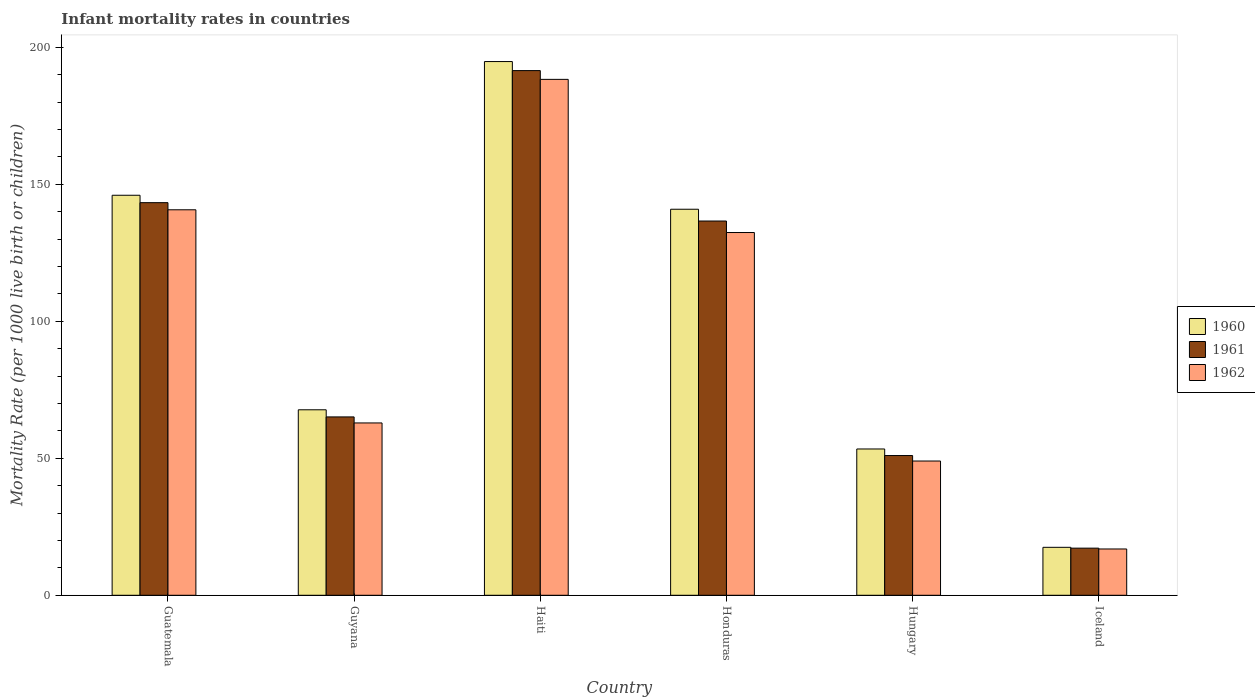How many different coloured bars are there?
Provide a succinct answer. 3. How many groups of bars are there?
Make the answer very short. 6. Are the number of bars per tick equal to the number of legend labels?
Offer a terse response. Yes. Are the number of bars on each tick of the X-axis equal?
Keep it short and to the point. Yes. How many bars are there on the 4th tick from the left?
Ensure brevity in your answer.  3. How many bars are there on the 6th tick from the right?
Your answer should be very brief. 3. What is the label of the 2nd group of bars from the left?
Ensure brevity in your answer.  Guyana. Across all countries, what is the maximum infant mortality rate in 1961?
Your answer should be compact. 191.5. Across all countries, what is the minimum infant mortality rate in 1962?
Your answer should be compact. 16.9. In which country was the infant mortality rate in 1962 maximum?
Offer a terse response. Haiti. What is the total infant mortality rate in 1960 in the graph?
Offer a very short reply. 620.3. What is the difference between the infant mortality rate in 1960 in Guyana and that in Honduras?
Offer a terse response. -73.2. What is the difference between the infant mortality rate in 1962 in Haiti and the infant mortality rate in 1961 in Honduras?
Make the answer very short. 51.7. What is the average infant mortality rate in 1960 per country?
Provide a succinct answer. 103.38. What is the difference between the infant mortality rate of/in 1961 and infant mortality rate of/in 1960 in Iceland?
Make the answer very short. -0.3. In how many countries, is the infant mortality rate in 1961 greater than 120?
Provide a succinct answer. 3. What is the ratio of the infant mortality rate in 1962 in Haiti to that in Honduras?
Provide a short and direct response. 1.42. What is the difference between the highest and the second highest infant mortality rate in 1961?
Your answer should be compact. 6.7. What is the difference between the highest and the lowest infant mortality rate in 1960?
Your response must be concise. 177.3. Is the sum of the infant mortality rate in 1961 in Hungary and Iceland greater than the maximum infant mortality rate in 1962 across all countries?
Offer a terse response. No. Is it the case that in every country, the sum of the infant mortality rate in 1961 and infant mortality rate in 1962 is greater than the infant mortality rate in 1960?
Offer a terse response. Yes. Are all the bars in the graph horizontal?
Offer a terse response. No. How many countries are there in the graph?
Keep it short and to the point. 6. What is the difference between two consecutive major ticks on the Y-axis?
Your answer should be very brief. 50. How many legend labels are there?
Offer a terse response. 3. What is the title of the graph?
Keep it short and to the point. Infant mortality rates in countries. Does "1968" appear as one of the legend labels in the graph?
Offer a very short reply. No. What is the label or title of the Y-axis?
Your answer should be compact. Mortality Rate (per 1000 live birth or children). What is the Mortality Rate (per 1000 live birth or children) of 1960 in Guatemala?
Your answer should be compact. 146. What is the Mortality Rate (per 1000 live birth or children) in 1961 in Guatemala?
Your response must be concise. 143.3. What is the Mortality Rate (per 1000 live birth or children) of 1962 in Guatemala?
Give a very brief answer. 140.7. What is the Mortality Rate (per 1000 live birth or children) of 1960 in Guyana?
Offer a terse response. 67.7. What is the Mortality Rate (per 1000 live birth or children) in 1961 in Guyana?
Keep it short and to the point. 65.1. What is the Mortality Rate (per 1000 live birth or children) of 1962 in Guyana?
Ensure brevity in your answer.  62.9. What is the Mortality Rate (per 1000 live birth or children) of 1960 in Haiti?
Make the answer very short. 194.8. What is the Mortality Rate (per 1000 live birth or children) of 1961 in Haiti?
Provide a short and direct response. 191.5. What is the Mortality Rate (per 1000 live birth or children) in 1962 in Haiti?
Ensure brevity in your answer.  188.3. What is the Mortality Rate (per 1000 live birth or children) of 1960 in Honduras?
Your response must be concise. 140.9. What is the Mortality Rate (per 1000 live birth or children) in 1961 in Honduras?
Keep it short and to the point. 136.6. What is the Mortality Rate (per 1000 live birth or children) of 1962 in Honduras?
Give a very brief answer. 132.4. What is the Mortality Rate (per 1000 live birth or children) in 1960 in Hungary?
Provide a succinct answer. 53.4. What is the Mortality Rate (per 1000 live birth or children) of 1961 in Iceland?
Make the answer very short. 17.2. Across all countries, what is the maximum Mortality Rate (per 1000 live birth or children) in 1960?
Offer a terse response. 194.8. Across all countries, what is the maximum Mortality Rate (per 1000 live birth or children) in 1961?
Your response must be concise. 191.5. Across all countries, what is the maximum Mortality Rate (per 1000 live birth or children) of 1962?
Offer a terse response. 188.3. Across all countries, what is the minimum Mortality Rate (per 1000 live birth or children) of 1961?
Provide a short and direct response. 17.2. Across all countries, what is the minimum Mortality Rate (per 1000 live birth or children) of 1962?
Your answer should be very brief. 16.9. What is the total Mortality Rate (per 1000 live birth or children) of 1960 in the graph?
Offer a very short reply. 620.3. What is the total Mortality Rate (per 1000 live birth or children) of 1961 in the graph?
Provide a succinct answer. 604.7. What is the total Mortality Rate (per 1000 live birth or children) in 1962 in the graph?
Offer a terse response. 590.2. What is the difference between the Mortality Rate (per 1000 live birth or children) in 1960 in Guatemala and that in Guyana?
Give a very brief answer. 78.3. What is the difference between the Mortality Rate (per 1000 live birth or children) in 1961 in Guatemala and that in Guyana?
Offer a terse response. 78.2. What is the difference between the Mortality Rate (per 1000 live birth or children) of 1962 in Guatemala and that in Guyana?
Your answer should be very brief. 77.8. What is the difference between the Mortality Rate (per 1000 live birth or children) in 1960 in Guatemala and that in Haiti?
Keep it short and to the point. -48.8. What is the difference between the Mortality Rate (per 1000 live birth or children) in 1961 in Guatemala and that in Haiti?
Provide a succinct answer. -48.2. What is the difference between the Mortality Rate (per 1000 live birth or children) of 1962 in Guatemala and that in Haiti?
Keep it short and to the point. -47.6. What is the difference between the Mortality Rate (per 1000 live birth or children) in 1961 in Guatemala and that in Honduras?
Keep it short and to the point. 6.7. What is the difference between the Mortality Rate (per 1000 live birth or children) of 1960 in Guatemala and that in Hungary?
Offer a terse response. 92.6. What is the difference between the Mortality Rate (per 1000 live birth or children) in 1961 in Guatemala and that in Hungary?
Offer a terse response. 92.3. What is the difference between the Mortality Rate (per 1000 live birth or children) of 1962 in Guatemala and that in Hungary?
Your answer should be compact. 91.7. What is the difference between the Mortality Rate (per 1000 live birth or children) in 1960 in Guatemala and that in Iceland?
Keep it short and to the point. 128.5. What is the difference between the Mortality Rate (per 1000 live birth or children) of 1961 in Guatemala and that in Iceland?
Your response must be concise. 126.1. What is the difference between the Mortality Rate (per 1000 live birth or children) of 1962 in Guatemala and that in Iceland?
Give a very brief answer. 123.8. What is the difference between the Mortality Rate (per 1000 live birth or children) of 1960 in Guyana and that in Haiti?
Offer a terse response. -127.1. What is the difference between the Mortality Rate (per 1000 live birth or children) of 1961 in Guyana and that in Haiti?
Make the answer very short. -126.4. What is the difference between the Mortality Rate (per 1000 live birth or children) of 1962 in Guyana and that in Haiti?
Make the answer very short. -125.4. What is the difference between the Mortality Rate (per 1000 live birth or children) in 1960 in Guyana and that in Honduras?
Keep it short and to the point. -73.2. What is the difference between the Mortality Rate (per 1000 live birth or children) in 1961 in Guyana and that in Honduras?
Make the answer very short. -71.5. What is the difference between the Mortality Rate (per 1000 live birth or children) in 1962 in Guyana and that in Honduras?
Your answer should be compact. -69.5. What is the difference between the Mortality Rate (per 1000 live birth or children) in 1960 in Guyana and that in Hungary?
Your answer should be compact. 14.3. What is the difference between the Mortality Rate (per 1000 live birth or children) of 1961 in Guyana and that in Hungary?
Give a very brief answer. 14.1. What is the difference between the Mortality Rate (per 1000 live birth or children) of 1960 in Guyana and that in Iceland?
Provide a short and direct response. 50.2. What is the difference between the Mortality Rate (per 1000 live birth or children) in 1961 in Guyana and that in Iceland?
Offer a very short reply. 47.9. What is the difference between the Mortality Rate (per 1000 live birth or children) in 1962 in Guyana and that in Iceland?
Give a very brief answer. 46. What is the difference between the Mortality Rate (per 1000 live birth or children) of 1960 in Haiti and that in Honduras?
Provide a succinct answer. 53.9. What is the difference between the Mortality Rate (per 1000 live birth or children) of 1961 in Haiti and that in Honduras?
Your response must be concise. 54.9. What is the difference between the Mortality Rate (per 1000 live birth or children) of 1962 in Haiti and that in Honduras?
Ensure brevity in your answer.  55.9. What is the difference between the Mortality Rate (per 1000 live birth or children) of 1960 in Haiti and that in Hungary?
Your answer should be compact. 141.4. What is the difference between the Mortality Rate (per 1000 live birth or children) of 1961 in Haiti and that in Hungary?
Your response must be concise. 140.5. What is the difference between the Mortality Rate (per 1000 live birth or children) of 1962 in Haiti and that in Hungary?
Your answer should be compact. 139.3. What is the difference between the Mortality Rate (per 1000 live birth or children) of 1960 in Haiti and that in Iceland?
Keep it short and to the point. 177.3. What is the difference between the Mortality Rate (per 1000 live birth or children) in 1961 in Haiti and that in Iceland?
Your answer should be compact. 174.3. What is the difference between the Mortality Rate (per 1000 live birth or children) of 1962 in Haiti and that in Iceland?
Your response must be concise. 171.4. What is the difference between the Mortality Rate (per 1000 live birth or children) of 1960 in Honduras and that in Hungary?
Your answer should be very brief. 87.5. What is the difference between the Mortality Rate (per 1000 live birth or children) of 1961 in Honduras and that in Hungary?
Offer a terse response. 85.6. What is the difference between the Mortality Rate (per 1000 live birth or children) of 1962 in Honduras and that in Hungary?
Keep it short and to the point. 83.4. What is the difference between the Mortality Rate (per 1000 live birth or children) of 1960 in Honduras and that in Iceland?
Offer a very short reply. 123.4. What is the difference between the Mortality Rate (per 1000 live birth or children) of 1961 in Honduras and that in Iceland?
Make the answer very short. 119.4. What is the difference between the Mortality Rate (per 1000 live birth or children) of 1962 in Honduras and that in Iceland?
Keep it short and to the point. 115.5. What is the difference between the Mortality Rate (per 1000 live birth or children) of 1960 in Hungary and that in Iceland?
Give a very brief answer. 35.9. What is the difference between the Mortality Rate (per 1000 live birth or children) in 1961 in Hungary and that in Iceland?
Your answer should be compact. 33.8. What is the difference between the Mortality Rate (per 1000 live birth or children) of 1962 in Hungary and that in Iceland?
Provide a succinct answer. 32.1. What is the difference between the Mortality Rate (per 1000 live birth or children) of 1960 in Guatemala and the Mortality Rate (per 1000 live birth or children) of 1961 in Guyana?
Provide a short and direct response. 80.9. What is the difference between the Mortality Rate (per 1000 live birth or children) in 1960 in Guatemala and the Mortality Rate (per 1000 live birth or children) in 1962 in Guyana?
Offer a terse response. 83.1. What is the difference between the Mortality Rate (per 1000 live birth or children) in 1961 in Guatemala and the Mortality Rate (per 1000 live birth or children) in 1962 in Guyana?
Offer a terse response. 80.4. What is the difference between the Mortality Rate (per 1000 live birth or children) of 1960 in Guatemala and the Mortality Rate (per 1000 live birth or children) of 1961 in Haiti?
Offer a terse response. -45.5. What is the difference between the Mortality Rate (per 1000 live birth or children) in 1960 in Guatemala and the Mortality Rate (per 1000 live birth or children) in 1962 in Haiti?
Offer a terse response. -42.3. What is the difference between the Mortality Rate (per 1000 live birth or children) of 1961 in Guatemala and the Mortality Rate (per 1000 live birth or children) of 1962 in Haiti?
Your response must be concise. -45. What is the difference between the Mortality Rate (per 1000 live birth or children) of 1961 in Guatemala and the Mortality Rate (per 1000 live birth or children) of 1962 in Honduras?
Provide a short and direct response. 10.9. What is the difference between the Mortality Rate (per 1000 live birth or children) of 1960 in Guatemala and the Mortality Rate (per 1000 live birth or children) of 1962 in Hungary?
Make the answer very short. 97. What is the difference between the Mortality Rate (per 1000 live birth or children) of 1961 in Guatemala and the Mortality Rate (per 1000 live birth or children) of 1962 in Hungary?
Give a very brief answer. 94.3. What is the difference between the Mortality Rate (per 1000 live birth or children) of 1960 in Guatemala and the Mortality Rate (per 1000 live birth or children) of 1961 in Iceland?
Provide a short and direct response. 128.8. What is the difference between the Mortality Rate (per 1000 live birth or children) of 1960 in Guatemala and the Mortality Rate (per 1000 live birth or children) of 1962 in Iceland?
Keep it short and to the point. 129.1. What is the difference between the Mortality Rate (per 1000 live birth or children) in 1961 in Guatemala and the Mortality Rate (per 1000 live birth or children) in 1962 in Iceland?
Ensure brevity in your answer.  126.4. What is the difference between the Mortality Rate (per 1000 live birth or children) in 1960 in Guyana and the Mortality Rate (per 1000 live birth or children) in 1961 in Haiti?
Offer a terse response. -123.8. What is the difference between the Mortality Rate (per 1000 live birth or children) in 1960 in Guyana and the Mortality Rate (per 1000 live birth or children) in 1962 in Haiti?
Your answer should be compact. -120.6. What is the difference between the Mortality Rate (per 1000 live birth or children) in 1961 in Guyana and the Mortality Rate (per 1000 live birth or children) in 1962 in Haiti?
Keep it short and to the point. -123.2. What is the difference between the Mortality Rate (per 1000 live birth or children) of 1960 in Guyana and the Mortality Rate (per 1000 live birth or children) of 1961 in Honduras?
Offer a very short reply. -68.9. What is the difference between the Mortality Rate (per 1000 live birth or children) in 1960 in Guyana and the Mortality Rate (per 1000 live birth or children) in 1962 in Honduras?
Offer a terse response. -64.7. What is the difference between the Mortality Rate (per 1000 live birth or children) of 1961 in Guyana and the Mortality Rate (per 1000 live birth or children) of 1962 in Honduras?
Your answer should be compact. -67.3. What is the difference between the Mortality Rate (per 1000 live birth or children) of 1961 in Guyana and the Mortality Rate (per 1000 live birth or children) of 1962 in Hungary?
Offer a terse response. 16.1. What is the difference between the Mortality Rate (per 1000 live birth or children) of 1960 in Guyana and the Mortality Rate (per 1000 live birth or children) of 1961 in Iceland?
Provide a succinct answer. 50.5. What is the difference between the Mortality Rate (per 1000 live birth or children) in 1960 in Guyana and the Mortality Rate (per 1000 live birth or children) in 1962 in Iceland?
Provide a succinct answer. 50.8. What is the difference between the Mortality Rate (per 1000 live birth or children) of 1961 in Guyana and the Mortality Rate (per 1000 live birth or children) of 1962 in Iceland?
Keep it short and to the point. 48.2. What is the difference between the Mortality Rate (per 1000 live birth or children) in 1960 in Haiti and the Mortality Rate (per 1000 live birth or children) in 1961 in Honduras?
Make the answer very short. 58.2. What is the difference between the Mortality Rate (per 1000 live birth or children) in 1960 in Haiti and the Mortality Rate (per 1000 live birth or children) in 1962 in Honduras?
Your answer should be compact. 62.4. What is the difference between the Mortality Rate (per 1000 live birth or children) in 1961 in Haiti and the Mortality Rate (per 1000 live birth or children) in 1962 in Honduras?
Provide a succinct answer. 59.1. What is the difference between the Mortality Rate (per 1000 live birth or children) of 1960 in Haiti and the Mortality Rate (per 1000 live birth or children) of 1961 in Hungary?
Your response must be concise. 143.8. What is the difference between the Mortality Rate (per 1000 live birth or children) of 1960 in Haiti and the Mortality Rate (per 1000 live birth or children) of 1962 in Hungary?
Your response must be concise. 145.8. What is the difference between the Mortality Rate (per 1000 live birth or children) of 1961 in Haiti and the Mortality Rate (per 1000 live birth or children) of 1962 in Hungary?
Your answer should be very brief. 142.5. What is the difference between the Mortality Rate (per 1000 live birth or children) in 1960 in Haiti and the Mortality Rate (per 1000 live birth or children) in 1961 in Iceland?
Your answer should be very brief. 177.6. What is the difference between the Mortality Rate (per 1000 live birth or children) in 1960 in Haiti and the Mortality Rate (per 1000 live birth or children) in 1962 in Iceland?
Your response must be concise. 177.9. What is the difference between the Mortality Rate (per 1000 live birth or children) of 1961 in Haiti and the Mortality Rate (per 1000 live birth or children) of 1962 in Iceland?
Keep it short and to the point. 174.6. What is the difference between the Mortality Rate (per 1000 live birth or children) of 1960 in Honduras and the Mortality Rate (per 1000 live birth or children) of 1961 in Hungary?
Your answer should be compact. 89.9. What is the difference between the Mortality Rate (per 1000 live birth or children) of 1960 in Honduras and the Mortality Rate (per 1000 live birth or children) of 1962 in Hungary?
Keep it short and to the point. 91.9. What is the difference between the Mortality Rate (per 1000 live birth or children) of 1961 in Honduras and the Mortality Rate (per 1000 live birth or children) of 1962 in Hungary?
Offer a very short reply. 87.6. What is the difference between the Mortality Rate (per 1000 live birth or children) of 1960 in Honduras and the Mortality Rate (per 1000 live birth or children) of 1961 in Iceland?
Provide a succinct answer. 123.7. What is the difference between the Mortality Rate (per 1000 live birth or children) in 1960 in Honduras and the Mortality Rate (per 1000 live birth or children) in 1962 in Iceland?
Offer a very short reply. 124. What is the difference between the Mortality Rate (per 1000 live birth or children) of 1961 in Honduras and the Mortality Rate (per 1000 live birth or children) of 1962 in Iceland?
Your answer should be very brief. 119.7. What is the difference between the Mortality Rate (per 1000 live birth or children) in 1960 in Hungary and the Mortality Rate (per 1000 live birth or children) in 1961 in Iceland?
Provide a short and direct response. 36.2. What is the difference between the Mortality Rate (per 1000 live birth or children) in 1960 in Hungary and the Mortality Rate (per 1000 live birth or children) in 1962 in Iceland?
Make the answer very short. 36.5. What is the difference between the Mortality Rate (per 1000 live birth or children) of 1961 in Hungary and the Mortality Rate (per 1000 live birth or children) of 1962 in Iceland?
Offer a very short reply. 34.1. What is the average Mortality Rate (per 1000 live birth or children) in 1960 per country?
Provide a succinct answer. 103.38. What is the average Mortality Rate (per 1000 live birth or children) of 1961 per country?
Keep it short and to the point. 100.78. What is the average Mortality Rate (per 1000 live birth or children) in 1962 per country?
Offer a very short reply. 98.37. What is the difference between the Mortality Rate (per 1000 live birth or children) of 1960 and Mortality Rate (per 1000 live birth or children) of 1961 in Guatemala?
Ensure brevity in your answer.  2.7. What is the difference between the Mortality Rate (per 1000 live birth or children) of 1960 and Mortality Rate (per 1000 live birth or children) of 1962 in Guyana?
Give a very brief answer. 4.8. What is the difference between the Mortality Rate (per 1000 live birth or children) of 1961 and Mortality Rate (per 1000 live birth or children) of 1962 in Guyana?
Ensure brevity in your answer.  2.2. What is the difference between the Mortality Rate (per 1000 live birth or children) in 1960 and Mortality Rate (per 1000 live birth or children) in 1961 in Haiti?
Provide a succinct answer. 3.3. What is the difference between the Mortality Rate (per 1000 live birth or children) in 1960 and Mortality Rate (per 1000 live birth or children) in 1962 in Haiti?
Offer a terse response. 6.5. What is the difference between the Mortality Rate (per 1000 live birth or children) of 1960 and Mortality Rate (per 1000 live birth or children) of 1961 in Honduras?
Offer a terse response. 4.3. What is the difference between the Mortality Rate (per 1000 live birth or children) in 1961 and Mortality Rate (per 1000 live birth or children) in 1962 in Honduras?
Keep it short and to the point. 4.2. What is the difference between the Mortality Rate (per 1000 live birth or children) in 1960 and Mortality Rate (per 1000 live birth or children) in 1961 in Iceland?
Offer a very short reply. 0.3. What is the difference between the Mortality Rate (per 1000 live birth or children) in 1960 and Mortality Rate (per 1000 live birth or children) in 1962 in Iceland?
Provide a succinct answer. 0.6. What is the difference between the Mortality Rate (per 1000 live birth or children) of 1961 and Mortality Rate (per 1000 live birth or children) of 1962 in Iceland?
Keep it short and to the point. 0.3. What is the ratio of the Mortality Rate (per 1000 live birth or children) of 1960 in Guatemala to that in Guyana?
Keep it short and to the point. 2.16. What is the ratio of the Mortality Rate (per 1000 live birth or children) of 1961 in Guatemala to that in Guyana?
Give a very brief answer. 2.2. What is the ratio of the Mortality Rate (per 1000 live birth or children) of 1962 in Guatemala to that in Guyana?
Keep it short and to the point. 2.24. What is the ratio of the Mortality Rate (per 1000 live birth or children) in 1960 in Guatemala to that in Haiti?
Keep it short and to the point. 0.75. What is the ratio of the Mortality Rate (per 1000 live birth or children) in 1961 in Guatemala to that in Haiti?
Give a very brief answer. 0.75. What is the ratio of the Mortality Rate (per 1000 live birth or children) in 1962 in Guatemala to that in Haiti?
Keep it short and to the point. 0.75. What is the ratio of the Mortality Rate (per 1000 live birth or children) of 1960 in Guatemala to that in Honduras?
Keep it short and to the point. 1.04. What is the ratio of the Mortality Rate (per 1000 live birth or children) in 1961 in Guatemala to that in Honduras?
Make the answer very short. 1.05. What is the ratio of the Mortality Rate (per 1000 live birth or children) of 1962 in Guatemala to that in Honduras?
Give a very brief answer. 1.06. What is the ratio of the Mortality Rate (per 1000 live birth or children) in 1960 in Guatemala to that in Hungary?
Your answer should be compact. 2.73. What is the ratio of the Mortality Rate (per 1000 live birth or children) in 1961 in Guatemala to that in Hungary?
Your response must be concise. 2.81. What is the ratio of the Mortality Rate (per 1000 live birth or children) of 1962 in Guatemala to that in Hungary?
Offer a terse response. 2.87. What is the ratio of the Mortality Rate (per 1000 live birth or children) of 1960 in Guatemala to that in Iceland?
Give a very brief answer. 8.34. What is the ratio of the Mortality Rate (per 1000 live birth or children) of 1961 in Guatemala to that in Iceland?
Give a very brief answer. 8.33. What is the ratio of the Mortality Rate (per 1000 live birth or children) in 1962 in Guatemala to that in Iceland?
Make the answer very short. 8.33. What is the ratio of the Mortality Rate (per 1000 live birth or children) of 1960 in Guyana to that in Haiti?
Give a very brief answer. 0.35. What is the ratio of the Mortality Rate (per 1000 live birth or children) of 1961 in Guyana to that in Haiti?
Provide a short and direct response. 0.34. What is the ratio of the Mortality Rate (per 1000 live birth or children) in 1962 in Guyana to that in Haiti?
Keep it short and to the point. 0.33. What is the ratio of the Mortality Rate (per 1000 live birth or children) of 1960 in Guyana to that in Honduras?
Your response must be concise. 0.48. What is the ratio of the Mortality Rate (per 1000 live birth or children) in 1961 in Guyana to that in Honduras?
Give a very brief answer. 0.48. What is the ratio of the Mortality Rate (per 1000 live birth or children) of 1962 in Guyana to that in Honduras?
Provide a succinct answer. 0.48. What is the ratio of the Mortality Rate (per 1000 live birth or children) in 1960 in Guyana to that in Hungary?
Provide a short and direct response. 1.27. What is the ratio of the Mortality Rate (per 1000 live birth or children) in 1961 in Guyana to that in Hungary?
Your answer should be compact. 1.28. What is the ratio of the Mortality Rate (per 1000 live birth or children) in 1962 in Guyana to that in Hungary?
Your answer should be compact. 1.28. What is the ratio of the Mortality Rate (per 1000 live birth or children) of 1960 in Guyana to that in Iceland?
Your response must be concise. 3.87. What is the ratio of the Mortality Rate (per 1000 live birth or children) in 1961 in Guyana to that in Iceland?
Your answer should be compact. 3.78. What is the ratio of the Mortality Rate (per 1000 live birth or children) in 1962 in Guyana to that in Iceland?
Provide a succinct answer. 3.72. What is the ratio of the Mortality Rate (per 1000 live birth or children) of 1960 in Haiti to that in Honduras?
Give a very brief answer. 1.38. What is the ratio of the Mortality Rate (per 1000 live birth or children) in 1961 in Haiti to that in Honduras?
Offer a very short reply. 1.4. What is the ratio of the Mortality Rate (per 1000 live birth or children) in 1962 in Haiti to that in Honduras?
Your answer should be compact. 1.42. What is the ratio of the Mortality Rate (per 1000 live birth or children) in 1960 in Haiti to that in Hungary?
Offer a very short reply. 3.65. What is the ratio of the Mortality Rate (per 1000 live birth or children) of 1961 in Haiti to that in Hungary?
Provide a succinct answer. 3.75. What is the ratio of the Mortality Rate (per 1000 live birth or children) in 1962 in Haiti to that in Hungary?
Give a very brief answer. 3.84. What is the ratio of the Mortality Rate (per 1000 live birth or children) in 1960 in Haiti to that in Iceland?
Give a very brief answer. 11.13. What is the ratio of the Mortality Rate (per 1000 live birth or children) of 1961 in Haiti to that in Iceland?
Offer a terse response. 11.13. What is the ratio of the Mortality Rate (per 1000 live birth or children) in 1962 in Haiti to that in Iceland?
Ensure brevity in your answer.  11.14. What is the ratio of the Mortality Rate (per 1000 live birth or children) in 1960 in Honduras to that in Hungary?
Ensure brevity in your answer.  2.64. What is the ratio of the Mortality Rate (per 1000 live birth or children) of 1961 in Honduras to that in Hungary?
Provide a short and direct response. 2.68. What is the ratio of the Mortality Rate (per 1000 live birth or children) in 1962 in Honduras to that in Hungary?
Your answer should be very brief. 2.7. What is the ratio of the Mortality Rate (per 1000 live birth or children) of 1960 in Honduras to that in Iceland?
Make the answer very short. 8.05. What is the ratio of the Mortality Rate (per 1000 live birth or children) in 1961 in Honduras to that in Iceland?
Keep it short and to the point. 7.94. What is the ratio of the Mortality Rate (per 1000 live birth or children) in 1962 in Honduras to that in Iceland?
Ensure brevity in your answer.  7.83. What is the ratio of the Mortality Rate (per 1000 live birth or children) of 1960 in Hungary to that in Iceland?
Your response must be concise. 3.05. What is the ratio of the Mortality Rate (per 1000 live birth or children) of 1961 in Hungary to that in Iceland?
Make the answer very short. 2.97. What is the ratio of the Mortality Rate (per 1000 live birth or children) in 1962 in Hungary to that in Iceland?
Provide a succinct answer. 2.9. What is the difference between the highest and the second highest Mortality Rate (per 1000 live birth or children) in 1960?
Your response must be concise. 48.8. What is the difference between the highest and the second highest Mortality Rate (per 1000 live birth or children) in 1961?
Your response must be concise. 48.2. What is the difference between the highest and the second highest Mortality Rate (per 1000 live birth or children) in 1962?
Offer a terse response. 47.6. What is the difference between the highest and the lowest Mortality Rate (per 1000 live birth or children) in 1960?
Your answer should be very brief. 177.3. What is the difference between the highest and the lowest Mortality Rate (per 1000 live birth or children) of 1961?
Ensure brevity in your answer.  174.3. What is the difference between the highest and the lowest Mortality Rate (per 1000 live birth or children) in 1962?
Keep it short and to the point. 171.4. 